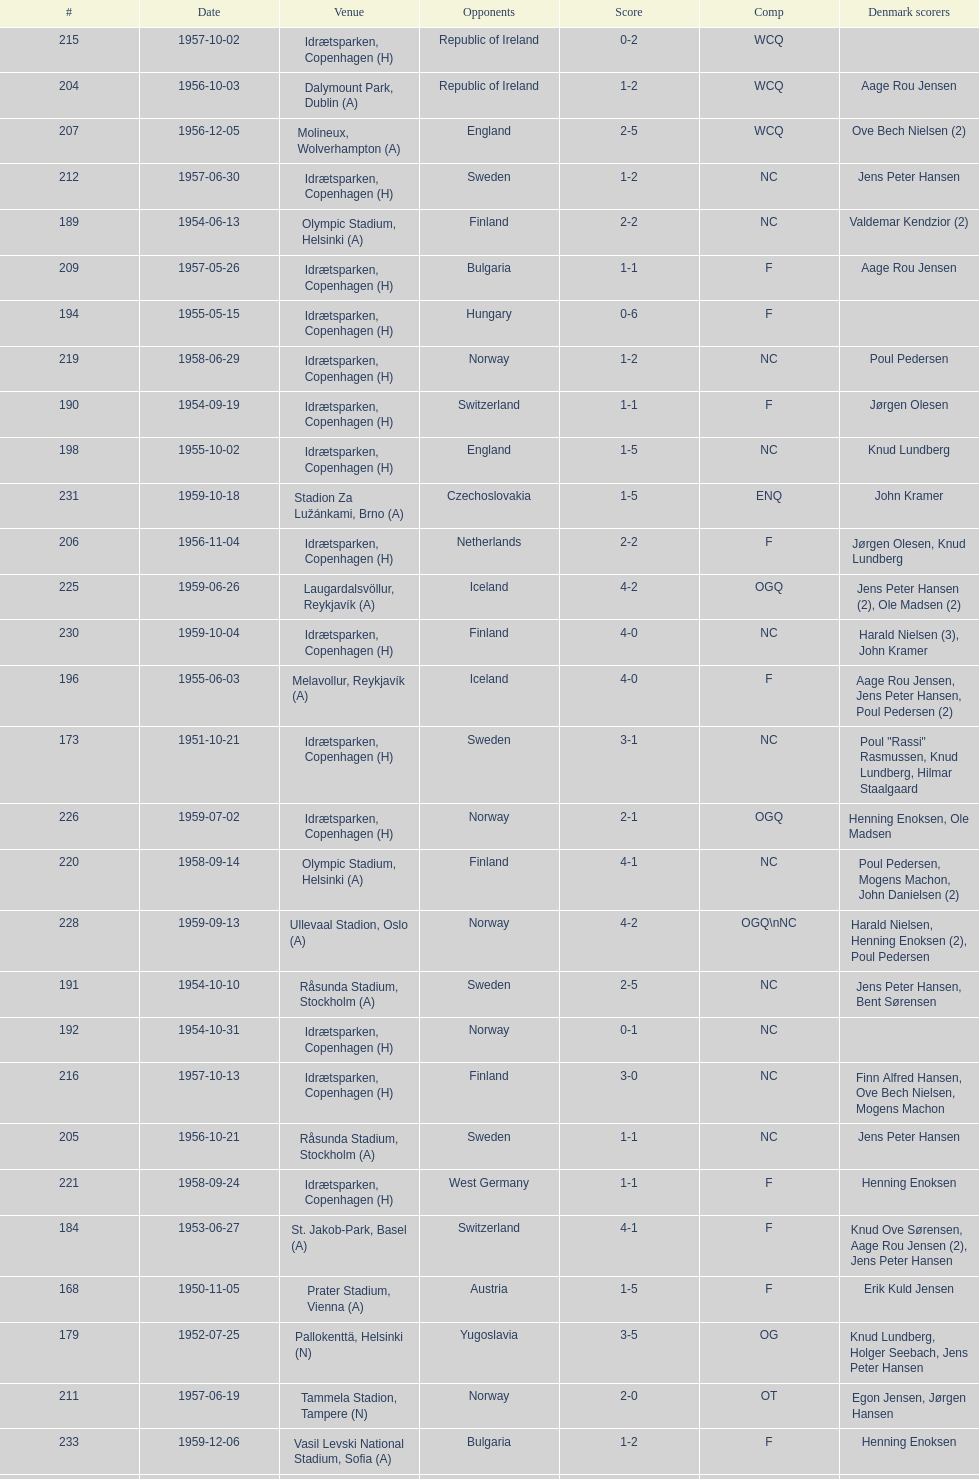Give me the full table as a dictionary. {'header': ['#', 'Date', 'Venue', 'Opponents', 'Score', 'Comp', 'Denmark scorers'], 'rows': [['215', '1957-10-02', 'Idrætsparken, Copenhagen (H)', 'Republic of Ireland', '0-2', 'WCQ', ''], ['204', '1956-10-03', 'Dalymount Park, Dublin (A)', 'Republic of Ireland', '1-2', 'WCQ', 'Aage Rou Jensen'], ['207', '1956-12-05', 'Molineux, Wolverhampton (A)', 'England', '2-5', 'WCQ', 'Ove Bech Nielsen (2)'], ['212', '1957-06-30', 'Idrætsparken, Copenhagen (H)', 'Sweden', '1-2', 'NC', 'Jens Peter Hansen'], ['189', '1954-06-13', 'Olympic Stadium, Helsinki (A)', 'Finland', '2-2', 'NC', 'Valdemar Kendzior (2)'], ['209', '1957-05-26', 'Idrætsparken, Copenhagen (H)', 'Bulgaria', '1-1', 'F', 'Aage Rou Jensen'], ['194', '1955-05-15', 'Idrætsparken, Copenhagen (H)', 'Hungary', '0-6', 'F', ''], ['219', '1958-06-29', 'Idrætsparken, Copenhagen (H)', 'Norway', '1-2', 'NC', 'Poul Pedersen'], ['190', '1954-09-19', 'Idrætsparken, Copenhagen (H)', 'Switzerland', '1-1', 'F', 'Jørgen Olesen'], ['198', '1955-10-02', 'Idrætsparken, Copenhagen (H)', 'England', '1-5', 'NC', 'Knud Lundberg'], ['231', '1959-10-18', 'Stadion Za Lužánkami, Brno (A)', 'Czechoslovakia', '1-5', 'ENQ', 'John Kramer'], ['206', '1956-11-04', 'Idrætsparken, Copenhagen (H)', 'Netherlands', '2-2', 'F', 'Jørgen Olesen, Knud Lundberg'], ['225', '1959-06-26', 'Laugardalsvöllur, Reykjavík (A)', 'Iceland', '4-2', 'OGQ', 'Jens Peter Hansen (2), Ole Madsen (2)'], ['230', '1959-10-04', 'Idrætsparken, Copenhagen (H)', 'Finland', '4-0', 'NC', 'Harald Nielsen (3), John Kramer'], ['196', '1955-06-03', 'Melavollur, Reykjavík (A)', 'Iceland', '4-0', 'F', 'Aage Rou Jensen, Jens Peter Hansen, Poul Pedersen (2)'], ['173', '1951-10-21', 'Idrætsparken, Copenhagen (H)', 'Sweden', '3-1', 'NC', 'Poul "Rassi" Rasmussen, Knud Lundberg, Hilmar Staalgaard'], ['226', '1959-07-02', 'Idrætsparken, Copenhagen (H)', 'Norway', '2-1', 'OGQ', 'Henning Enoksen, Ole Madsen'], ['220', '1958-09-14', 'Olympic Stadium, Helsinki (A)', 'Finland', '4-1', 'NC', 'Poul Pedersen, Mogens Machon, John Danielsen (2)'], ['228', '1959-09-13', 'Ullevaal Stadion, Oslo (A)', 'Norway', '4-2', 'OGQ\\nNC', 'Harald Nielsen, Henning Enoksen (2), Poul Pedersen'], ['191', '1954-10-10', 'Råsunda Stadium, Stockholm (A)', 'Sweden', '2-5', 'NC', 'Jens Peter Hansen, Bent Sørensen'], ['192', '1954-10-31', 'Idrætsparken, Copenhagen (H)', 'Norway', '0-1', 'NC', ''], ['216', '1957-10-13', 'Idrætsparken, Copenhagen (H)', 'Finland', '3-0', 'NC', 'Finn Alfred Hansen, Ove Bech Nielsen, Mogens Machon'], ['205', '1956-10-21', 'Råsunda Stadium, Stockholm (A)', 'Sweden', '1-1', 'NC', 'Jens Peter Hansen'], ['221', '1958-09-24', 'Idrætsparken, Copenhagen (H)', 'West Germany', '1-1', 'F', 'Henning Enoksen'], ['184', '1953-06-27', 'St. Jakob-Park, Basel (A)', 'Switzerland', '4-1', 'F', 'Knud Ove Sørensen, Aage Rou Jensen (2), Jens Peter Hansen'], ['168', '1950-11-05', 'Prater Stadium, Vienna (A)', 'Austria', '1-5', 'F', 'Erik Kuld Jensen'], ['179', '1952-07-25', 'Pallokenttä, Helsinki (N)', 'Yugoslavia', '3-5', 'OG', 'Knud Lundberg, Holger Seebach, Jens Peter Hansen'], ['211', '1957-06-19', 'Tammela Stadion, Tampere (N)', 'Norway', '2-0', 'OT', 'Egon Jensen, Jørgen Hansen'], ['233', '1959-12-06', 'Vasil Levski National Stadium, Sofia (A)', 'Bulgaria', '1-2', 'F', 'Henning Enoksen'], ['187', '1953-10-04', 'Idrætsparken, Copenhagen (H)', 'Finland', '6-1', 'NC', 'Jens Peter Hansen (2), Poul Erik "Popper" Petersen, Bent Sørensen, Kurt "Nikkelaj" Nielsen (2)'], ['223', '1958-10-26', 'Råsunda Stadium, Stockholm (A)', 'Sweden', '4-4', 'NC', 'Ole Madsen (2), Henning Enoksen, Jørn Sørensen'], ['180', '1952-09-21', 'Idrætsparken, Copenhagen (H)', 'Netherlands', '3-2', 'F', 'Kurt "Nikkelaj" Nielsen, Poul Erik "Popper" Petersen'], ['174', '1952-05-25', 'Idrætsparken, Copenhagen (H)', 'Scotland', '1-2', 'F', 'Poul "Rassi" Rasmussen'], ['162', '1950-05-28', 'JNA Stadium, Belgrade (A)', 'Yugoslavia', '1-5', 'F', 'Axel Pilmark'], ['201', '1956-06-24', 'Idrætsparken, Copenhagen (H)', 'Norway', '2-3', 'NC', 'Knud Lundberg, Poul Pedersen'], ['232', '1959-12-02', 'Olympic Stadium, Athens (A)', 'Greece', '3-1', 'F', 'Henning Enoksen (2), Poul Pedersen'], ['175', '1952-06-11', 'Bislett Stadium, Oslo (N)', 'Sweden', '0-2', 'OT', ''], ['218', '1958-05-25', 'Idrætsparken, Copenhagen (H)', 'Poland', '3-2', 'F', 'Jørn Sørensen, Poul Pedersen (2)'], ['214', '1957-09-22', 'Ullevaal Stadion, Oslo (A)', 'Norway', '2-2', 'NC', 'Poul Pedersen, Peder Kjær'], ['217', '1958-05-15', 'Aarhus Stadion, Aarhus (H)', 'Curaçao', '3-2', 'F', 'Poul Pedersen, Henning Enoksen (2)'], ['188', '1954-06-04', 'Malmö Idrottsplats, Malmö (N)', 'Norway', '1-2\\n(aet)', 'OT', 'Valdemar Kendzior'], ['165', '1950-08-27', 'Olympic Stadium, Helsinki (A)', 'Finland', '2-1', 'NC', 'Poul Erik "Popper" Petersen, Holger Seebach'], ['227', '1959-08-18', 'Idrætsparken, Copenhagen (H)', 'Iceland', '1-1', 'OGQ', 'Henning Enoksen'], ['167', '1950-10-15', 'Råsunda Stadium, Stockholm (A)', 'Sweden', '0-4', 'NC', ''], ['197', '1955-09-11', 'Ullevaal Stadion, Oslo (A)', 'Norway', '1-1', 'NC', 'Jørgen Jacobsen'], ['181', '1952-10-05', 'Olympic Stadium, Helsinki (A)', 'Finland', '1-2', 'NC', 'Per Jensen'], ['202', '1956-07-01', 'Idrætsparken, Copenhagen (H)', 'USSR', '2-5', 'F', 'Ove Andersen, Aage Rou Jensen'], ['169', '1951-05-12', 'Hampden Park, Glasgow (A)', 'Scotland', '1-3', 'F', 'Jørgen W. Hansen'], ['176', '1952-06-22', 'Råsunda Stadium, Stockholm (A)', 'Sweden', '3-4', 'NC', 'Poul "Rassi" Rasmussen, Poul Erik "Popper" Petersen, Holger Seebach'], ['203', '1956-09-16', 'Olympic Stadium, Helsinki (A)', 'Finland', '4-0', 'NC', 'Poul Pedersen, Jørgen Hansen, Ove Andersen (2)'], ['210', '1957-06-18', 'Olympic Stadium, Helsinki (A)', 'Finland', '0-2', 'OT', ''], ['182', '1952-10-19', 'Idrætsparken, Copenhagen (H)', 'Norway', '1-3', 'NC', 'Per Jensen'], ['186', '1953-09-13', 'Ullevaal Stadion, Oslo (A)', 'Norway', '1-0', 'NC', 'Bent Sørensen'], ['164', '1950-06-25', 'Aarhus Stadion, Aarhus (H)', 'Norway', '1-4', 'NC', 'Aage Rou Jensen'], ['213', '1957-07-10', 'Laugardalsvöllur, Reykjavík (A)', 'Iceland', '6-2', 'OT', 'Egon Jensen (3), Poul Pedersen, Jens Peter Hansen (2)'], ['185', '1953-08-09', 'Idrætsparken, Copenhagen (H)', 'Iceland', '4-0', 'F', 'Holger Seebach (2), Erik Nielsen, Erik Hansen'], ['170', '1951-06-17', 'Idrætsparken, Copenhagen (H)', 'Austria', '3-3', 'F', 'Aage Rou Jensen (2), Knud Lundberg'], ['183', '1953-06-21', 'Idrætsparken, Copenhagen (H)', 'Sweden', '1-3', 'NC', 'Holger Seebach'], ['224', '1959-06-21', 'Idrætsparken, Copenhagen (H)', 'Sweden', '0-6', 'NC', ''], ['193', '1955-03-13', 'Olympic Stadium, Amsterdam (A)', 'Netherlands', '1-1', 'F', 'Vagn Birkeland'], ['163', '1950-06-22', 'Idrætsparken, Copenhagen (H)', 'Norway', '4-0', 'NC', 'Poul Erik "Popper" Petersen, Edwin Hansen, Jens Peter Hansen, Aage Rou Jensen'], ['166', '1950-09-10', 'Idrætsparken, Copenhagen (H)', 'Yugoslavia', '1-4', 'F', 'Edwin Hansen'], ['177', '1952-07-15', 'Tammela Stadion, Tampere (N)', 'Greece', '2-1', 'OG', 'Poul Erik "Popper" Petersen, Holger Seebach'], ['195', '1955-06-19', 'Idrætsparken, Copenhagen (H)', 'Finland', '2-1', 'NC', 'Jens Peter Hansen (2)'], ['200', '1956-05-23', 'Dynamo Stadium, Moscow (A)', 'USSR', '1-5', 'F', 'Knud Lundberg'], ['171', '1951-09-16', 'Ullevaal Stadion, Oslo (A)', 'Norway', '0-2', 'NC', ''], ['208', '1957-05-15', 'Idrætsparken, Copenhagen (H)', 'England', '1-4', 'WCQ', 'John Jensen'], ['222', '1958-10-15', 'Idrætsparken, Copenhagen (H)', 'Netherlands', '1-5', 'F', 'Henning Enoksen'], ['172', '1951-09-30', 'Idrætsparken, Copenhagen (H)', 'Finland', '1-0', 'NC', 'Hilmar Staalgaard'], ['229', '1959-09-23', 'Idrætsparken, Copenhagen (H)', 'Czechoslovakia', '2-2', 'ENQ', 'Poul Pedersen, Bent Hansen'], ['199', '1955-10-16', 'Idrætsparken, Copenhagen (H)', 'Sweden', '3-3', 'NC', 'Ove Andersen (2), Knud Lundberg'], ['178', '1952-07-21', 'Kupittaa Stadion, Turku (N)', 'Poland', '2-0', 'OG', 'Holger Seebach, Svend "Boston" Nielsen']]} How many times was poland the opponent? 2. 